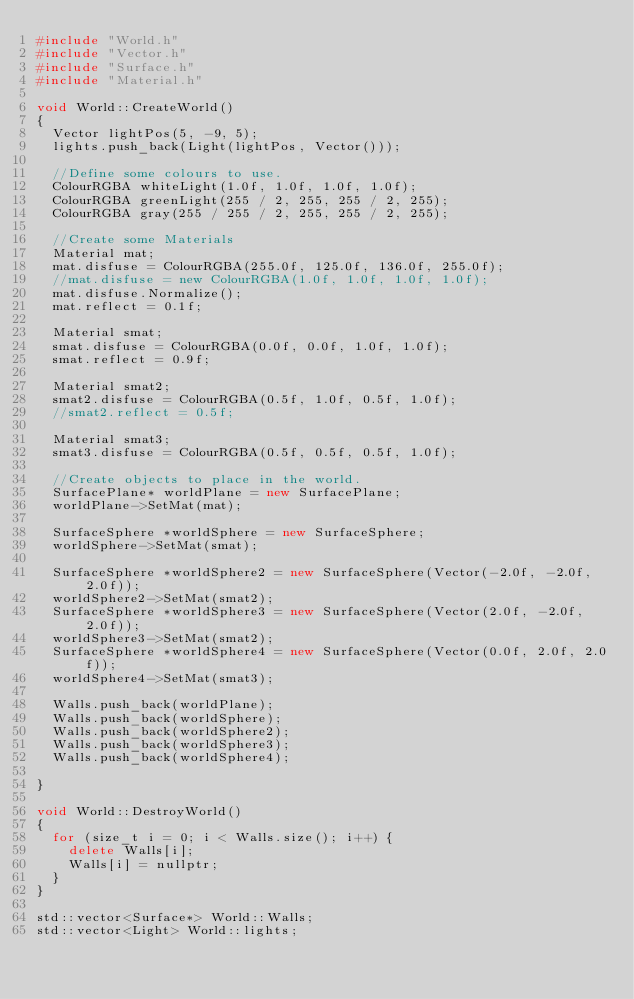<code> <loc_0><loc_0><loc_500><loc_500><_C++_>#include "World.h"
#include "Vector.h"
#include "Surface.h"
#include "Material.h"

void World::CreateWorld()
{
	Vector lightPos(5, -9, 5);
	lights.push_back(Light(lightPos, Vector()));

	//Define some colours to use.
	ColourRGBA whiteLight(1.0f, 1.0f, 1.0f, 1.0f);
	ColourRGBA greenLight(255 / 2, 255, 255 / 2, 255);
	ColourRGBA gray(255 / 255 / 2, 255, 255 / 2, 255);

	//Create some Materials
	Material mat;
	mat.disfuse = ColourRGBA(255.0f, 125.0f, 136.0f, 255.0f);
	//mat.disfuse = new ColourRGBA(1.0f, 1.0f, 1.0f, 1.0f);
	mat.disfuse.Normalize();
	mat.reflect = 0.1f;

	Material smat;
	smat.disfuse = ColourRGBA(0.0f, 0.0f, 1.0f, 1.0f);
	smat.reflect = 0.9f;

	Material smat2;
	smat2.disfuse = ColourRGBA(0.5f, 1.0f, 0.5f, 1.0f);
	//smat2.reflect = 0.5f;

	Material smat3;
	smat3.disfuse = ColourRGBA(0.5f, 0.5f, 0.5f, 1.0f);

	//Create objects to place in the world.
	SurfacePlane* worldPlane = new SurfacePlane;
	worldPlane->SetMat(mat);

	SurfaceSphere *worldSphere = new SurfaceSphere;
	worldSphere->SetMat(smat);

	SurfaceSphere *worldSphere2 = new SurfaceSphere(Vector(-2.0f, -2.0f, 2.0f));
	worldSphere2->SetMat(smat2);
	SurfaceSphere *worldSphere3 = new SurfaceSphere(Vector(2.0f, -2.0f, 2.0f));
	worldSphere3->SetMat(smat2);
	SurfaceSphere *worldSphere4 = new SurfaceSphere(Vector(0.0f, 2.0f, 2.0f));
	worldSphere4->SetMat(smat3);

	Walls.push_back(worldPlane);
	Walls.push_back(worldSphere);
	Walls.push_back(worldSphere2);
	Walls.push_back(worldSphere3);
	Walls.push_back(worldSphere4);

}

void World::DestroyWorld()
{
	for (size_t i = 0; i < Walls.size(); i++) {
		delete Walls[i];
		Walls[i] = nullptr;
	}
}

std::vector<Surface*> World::Walls;
std::vector<Light> World::lights;</code> 